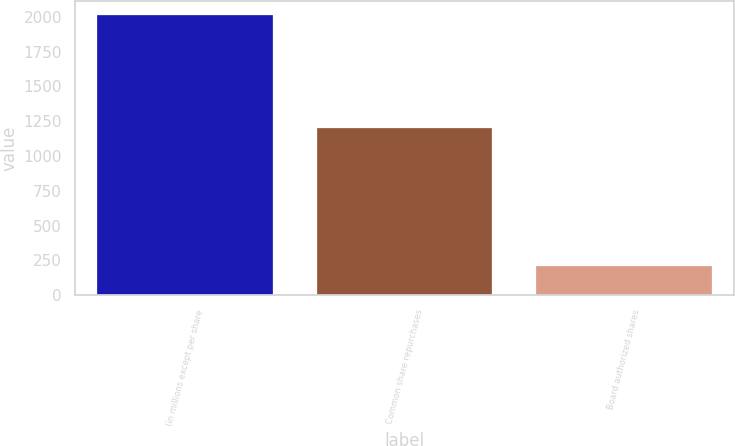Convert chart. <chart><loc_0><loc_0><loc_500><loc_500><bar_chart><fcel>(in millions except per share<fcel>Common share repurchases<fcel>Board authorized shares<nl><fcel>2015<fcel>1200<fcel>211.4<nl></chart> 